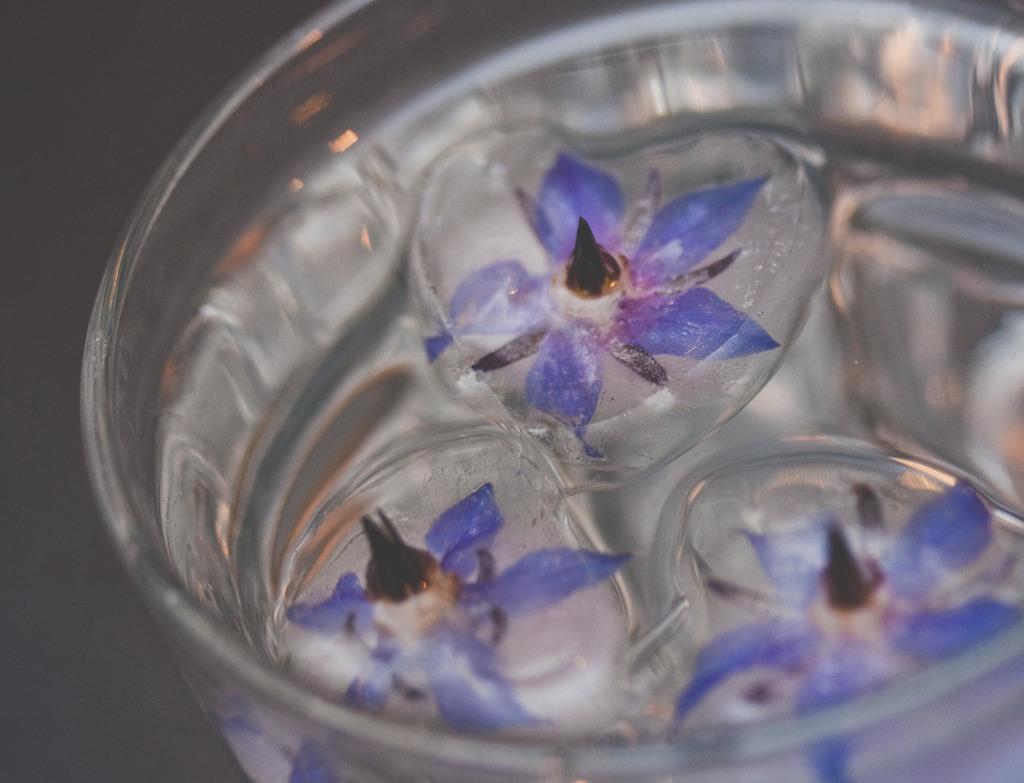Can you describe this image briefly? In this picture we can see few ice cubes and flowers in the glass. 